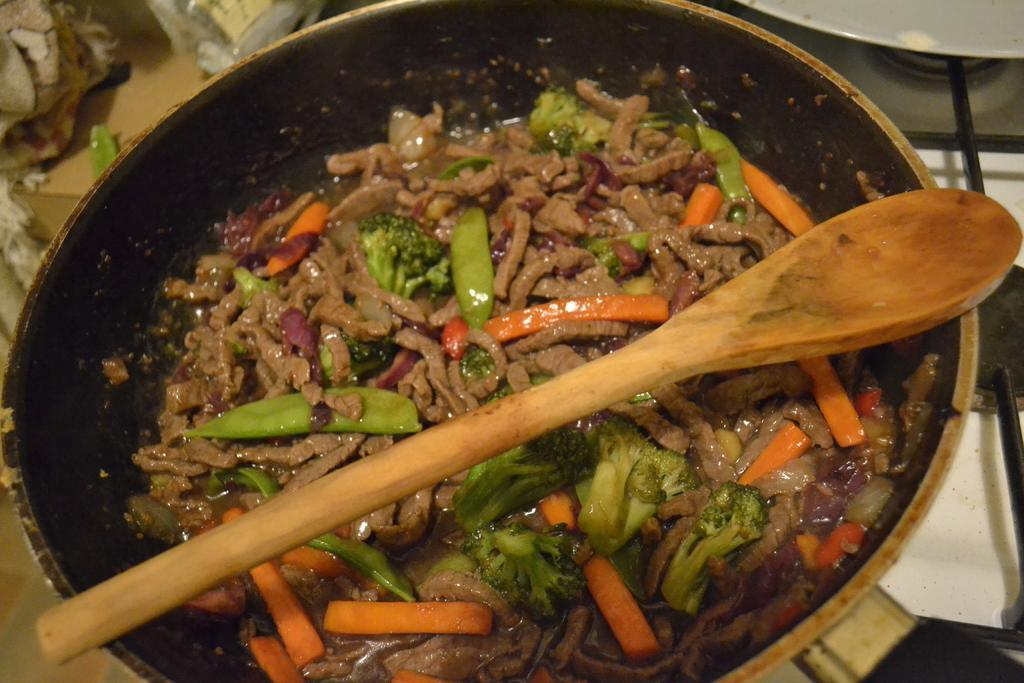What type of vegetables can be seen in the image? There are slices of carrots, beans, and broccoli in the image. What else is present in the image besides vegetables? There are other food items in the image. How are the food items arranged in the image? The food items are in a pan. What is on top of the pan in the image? There is a pan stick on top of the pan. Where is the pan located in the image? The pan is placed on a table. What type of comfort can be seen in the image? There is no comfort present in the image; it features food items in a pan. Is there a scarf visible in the image? No, there is no scarf present in the image. 